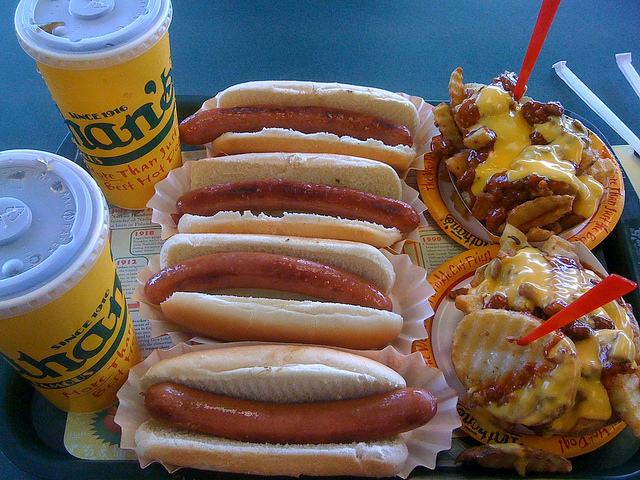Read and extract the text from this image. 1916 SINCE Than 1000 Nathan's 1012 Bert han 